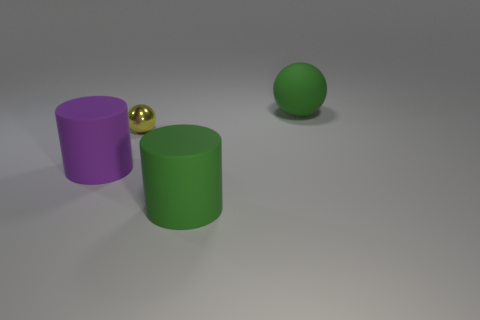What material is the other cylinder that is the same size as the purple cylinder?
Keep it short and to the point. Rubber. What is the big green object that is right of the large green thing in front of the ball that is on the right side of the green rubber cylinder made of?
Provide a short and direct response. Rubber. The shiny thing has what color?
Offer a very short reply. Yellow. What number of large things are green cylinders or spheres?
Your answer should be compact. 2. There is a object that is the same color as the big sphere; what material is it?
Make the answer very short. Rubber. Do the big green object in front of the purple rubber object and the cylinder to the left of the yellow metallic thing have the same material?
Give a very brief answer. Yes. Are there any large purple rubber objects?
Your answer should be compact. Yes. Is the number of big objects that are in front of the tiny ball greater than the number of small yellow metallic things that are behind the large ball?
Offer a terse response. Yes. There is a large green object that is the same shape as the purple object; what is it made of?
Make the answer very short. Rubber. Is there any other thing that is the same size as the purple cylinder?
Offer a terse response. Yes. 